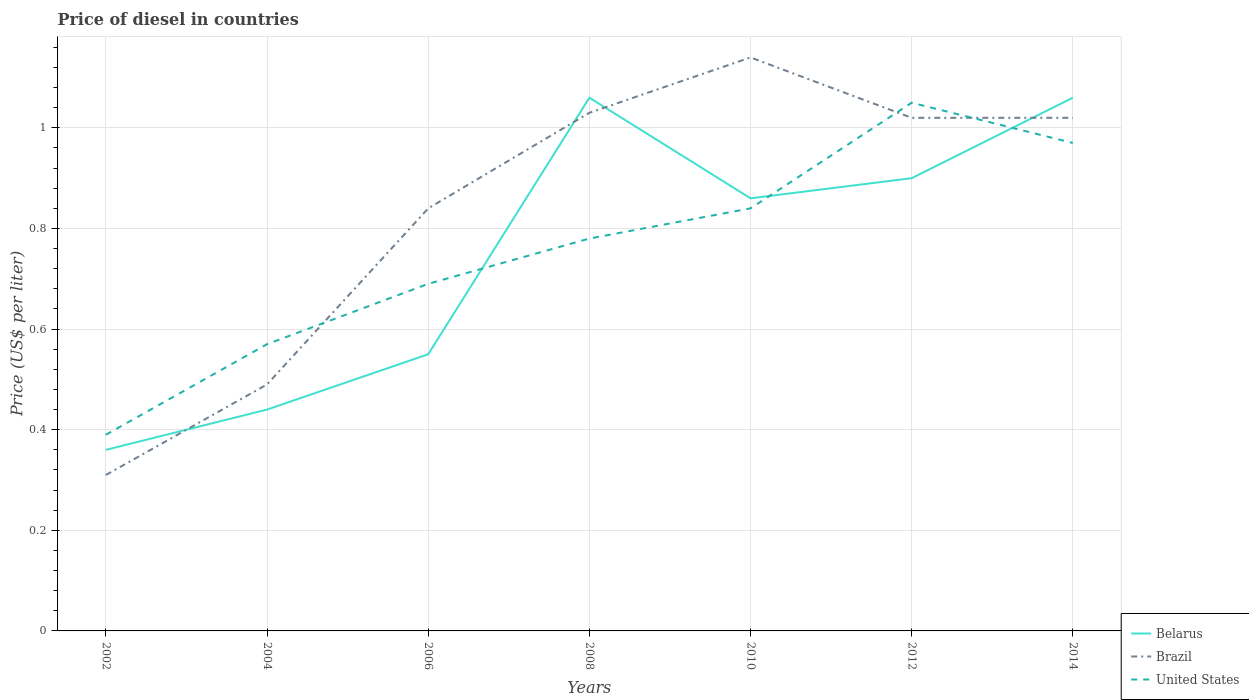How many different coloured lines are there?
Make the answer very short. 3. Does the line corresponding to Brazil intersect with the line corresponding to Belarus?
Make the answer very short. Yes. Across all years, what is the maximum price of diesel in Brazil?
Make the answer very short. 0.31. What is the total price of diesel in Belarus in the graph?
Offer a very short reply. -0.31. What is the difference between the highest and the second highest price of diesel in Brazil?
Provide a succinct answer. 0.83. Is the price of diesel in United States strictly greater than the price of diesel in Belarus over the years?
Make the answer very short. No. How many lines are there?
Ensure brevity in your answer.  3. How many years are there in the graph?
Provide a short and direct response. 7. What is the difference between two consecutive major ticks on the Y-axis?
Offer a terse response. 0.2. Does the graph contain grids?
Offer a very short reply. Yes. How many legend labels are there?
Offer a very short reply. 3. What is the title of the graph?
Give a very brief answer. Price of diesel in countries. What is the label or title of the Y-axis?
Ensure brevity in your answer.  Price (US$ per liter). What is the Price (US$ per liter) of Belarus in 2002?
Provide a succinct answer. 0.36. What is the Price (US$ per liter) of Brazil in 2002?
Your response must be concise. 0.31. What is the Price (US$ per liter) of United States in 2002?
Give a very brief answer. 0.39. What is the Price (US$ per liter) in Belarus in 2004?
Your response must be concise. 0.44. What is the Price (US$ per liter) in Brazil in 2004?
Provide a succinct answer. 0.49. What is the Price (US$ per liter) in United States in 2004?
Offer a terse response. 0.57. What is the Price (US$ per liter) in Belarus in 2006?
Offer a very short reply. 0.55. What is the Price (US$ per liter) in Brazil in 2006?
Your response must be concise. 0.84. What is the Price (US$ per liter) in United States in 2006?
Make the answer very short. 0.69. What is the Price (US$ per liter) of Belarus in 2008?
Offer a terse response. 1.06. What is the Price (US$ per liter) of Brazil in 2008?
Keep it short and to the point. 1.03. What is the Price (US$ per liter) in United States in 2008?
Your answer should be very brief. 0.78. What is the Price (US$ per liter) in Belarus in 2010?
Your answer should be very brief. 0.86. What is the Price (US$ per liter) in Brazil in 2010?
Keep it short and to the point. 1.14. What is the Price (US$ per liter) of United States in 2010?
Offer a terse response. 0.84. What is the Price (US$ per liter) in United States in 2012?
Provide a short and direct response. 1.05. What is the Price (US$ per liter) in Belarus in 2014?
Offer a terse response. 1.06. Across all years, what is the maximum Price (US$ per liter) of Belarus?
Keep it short and to the point. 1.06. Across all years, what is the maximum Price (US$ per liter) in Brazil?
Provide a short and direct response. 1.14. Across all years, what is the minimum Price (US$ per liter) of Belarus?
Keep it short and to the point. 0.36. Across all years, what is the minimum Price (US$ per liter) in Brazil?
Provide a short and direct response. 0.31. Across all years, what is the minimum Price (US$ per liter) in United States?
Provide a short and direct response. 0.39. What is the total Price (US$ per liter) of Belarus in the graph?
Provide a short and direct response. 5.23. What is the total Price (US$ per liter) of Brazil in the graph?
Offer a terse response. 5.85. What is the total Price (US$ per liter) of United States in the graph?
Give a very brief answer. 5.29. What is the difference between the Price (US$ per liter) of Belarus in 2002 and that in 2004?
Offer a terse response. -0.08. What is the difference between the Price (US$ per liter) of Brazil in 2002 and that in 2004?
Your answer should be very brief. -0.18. What is the difference between the Price (US$ per liter) in United States in 2002 and that in 2004?
Offer a very short reply. -0.18. What is the difference between the Price (US$ per liter) in Belarus in 2002 and that in 2006?
Offer a very short reply. -0.19. What is the difference between the Price (US$ per liter) in Brazil in 2002 and that in 2006?
Offer a very short reply. -0.53. What is the difference between the Price (US$ per liter) in Brazil in 2002 and that in 2008?
Make the answer very short. -0.72. What is the difference between the Price (US$ per liter) of United States in 2002 and that in 2008?
Your response must be concise. -0.39. What is the difference between the Price (US$ per liter) in Belarus in 2002 and that in 2010?
Offer a terse response. -0.5. What is the difference between the Price (US$ per liter) of Brazil in 2002 and that in 2010?
Ensure brevity in your answer.  -0.83. What is the difference between the Price (US$ per liter) of United States in 2002 and that in 2010?
Make the answer very short. -0.45. What is the difference between the Price (US$ per liter) in Belarus in 2002 and that in 2012?
Provide a succinct answer. -0.54. What is the difference between the Price (US$ per liter) in Brazil in 2002 and that in 2012?
Your answer should be compact. -0.71. What is the difference between the Price (US$ per liter) in United States in 2002 and that in 2012?
Your answer should be compact. -0.66. What is the difference between the Price (US$ per liter) in Brazil in 2002 and that in 2014?
Your response must be concise. -0.71. What is the difference between the Price (US$ per liter) in United States in 2002 and that in 2014?
Ensure brevity in your answer.  -0.58. What is the difference between the Price (US$ per liter) in Belarus in 2004 and that in 2006?
Provide a succinct answer. -0.11. What is the difference between the Price (US$ per liter) of Brazil in 2004 and that in 2006?
Keep it short and to the point. -0.35. What is the difference between the Price (US$ per liter) of United States in 2004 and that in 2006?
Provide a short and direct response. -0.12. What is the difference between the Price (US$ per liter) in Belarus in 2004 and that in 2008?
Offer a terse response. -0.62. What is the difference between the Price (US$ per liter) in Brazil in 2004 and that in 2008?
Offer a terse response. -0.54. What is the difference between the Price (US$ per liter) of United States in 2004 and that in 2008?
Give a very brief answer. -0.21. What is the difference between the Price (US$ per liter) of Belarus in 2004 and that in 2010?
Offer a very short reply. -0.42. What is the difference between the Price (US$ per liter) of Brazil in 2004 and that in 2010?
Keep it short and to the point. -0.65. What is the difference between the Price (US$ per liter) of United States in 2004 and that in 2010?
Provide a succinct answer. -0.27. What is the difference between the Price (US$ per liter) in Belarus in 2004 and that in 2012?
Provide a short and direct response. -0.46. What is the difference between the Price (US$ per liter) of Brazil in 2004 and that in 2012?
Keep it short and to the point. -0.53. What is the difference between the Price (US$ per liter) in United States in 2004 and that in 2012?
Your answer should be compact. -0.48. What is the difference between the Price (US$ per liter) in Belarus in 2004 and that in 2014?
Your response must be concise. -0.62. What is the difference between the Price (US$ per liter) in Brazil in 2004 and that in 2014?
Offer a very short reply. -0.53. What is the difference between the Price (US$ per liter) in Belarus in 2006 and that in 2008?
Your response must be concise. -0.51. What is the difference between the Price (US$ per liter) of Brazil in 2006 and that in 2008?
Keep it short and to the point. -0.19. What is the difference between the Price (US$ per liter) in United States in 2006 and that in 2008?
Make the answer very short. -0.09. What is the difference between the Price (US$ per liter) in Belarus in 2006 and that in 2010?
Your answer should be very brief. -0.31. What is the difference between the Price (US$ per liter) in United States in 2006 and that in 2010?
Your answer should be compact. -0.15. What is the difference between the Price (US$ per liter) of Belarus in 2006 and that in 2012?
Offer a terse response. -0.35. What is the difference between the Price (US$ per liter) of Brazil in 2006 and that in 2012?
Offer a very short reply. -0.18. What is the difference between the Price (US$ per liter) in United States in 2006 and that in 2012?
Give a very brief answer. -0.36. What is the difference between the Price (US$ per liter) of Belarus in 2006 and that in 2014?
Keep it short and to the point. -0.51. What is the difference between the Price (US$ per liter) in Brazil in 2006 and that in 2014?
Provide a short and direct response. -0.18. What is the difference between the Price (US$ per liter) in United States in 2006 and that in 2014?
Your answer should be very brief. -0.28. What is the difference between the Price (US$ per liter) of Belarus in 2008 and that in 2010?
Your response must be concise. 0.2. What is the difference between the Price (US$ per liter) in Brazil in 2008 and that in 2010?
Make the answer very short. -0.11. What is the difference between the Price (US$ per liter) in United States in 2008 and that in 2010?
Make the answer very short. -0.06. What is the difference between the Price (US$ per liter) in Belarus in 2008 and that in 2012?
Keep it short and to the point. 0.16. What is the difference between the Price (US$ per liter) in Brazil in 2008 and that in 2012?
Provide a short and direct response. 0.01. What is the difference between the Price (US$ per liter) in United States in 2008 and that in 2012?
Your answer should be very brief. -0.27. What is the difference between the Price (US$ per liter) in United States in 2008 and that in 2014?
Offer a terse response. -0.19. What is the difference between the Price (US$ per liter) of Belarus in 2010 and that in 2012?
Give a very brief answer. -0.04. What is the difference between the Price (US$ per liter) in Brazil in 2010 and that in 2012?
Offer a terse response. 0.12. What is the difference between the Price (US$ per liter) in United States in 2010 and that in 2012?
Provide a succinct answer. -0.21. What is the difference between the Price (US$ per liter) in Brazil in 2010 and that in 2014?
Provide a short and direct response. 0.12. What is the difference between the Price (US$ per liter) of United States in 2010 and that in 2014?
Provide a short and direct response. -0.13. What is the difference between the Price (US$ per liter) in Belarus in 2012 and that in 2014?
Your response must be concise. -0.16. What is the difference between the Price (US$ per liter) of Brazil in 2012 and that in 2014?
Your answer should be very brief. 0. What is the difference between the Price (US$ per liter) of United States in 2012 and that in 2014?
Offer a very short reply. 0.08. What is the difference between the Price (US$ per liter) in Belarus in 2002 and the Price (US$ per liter) in Brazil in 2004?
Ensure brevity in your answer.  -0.13. What is the difference between the Price (US$ per liter) in Belarus in 2002 and the Price (US$ per liter) in United States in 2004?
Your answer should be compact. -0.21. What is the difference between the Price (US$ per liter) in Brazil in 2002 and the Price (US$ per liter) in United States in 2004?
Make the answer very short. -0.26. What is the difference between the Price (US$ per liter) of Belarus in 2002 and the Price (US$ per liter) of Brazil in 2006?
Provide a succinct answer. -0.48. What is the difference between the Price (US$ per liter) of Belarus in 2002 and the Price (US$ per liter) of United States in 2006?
Keep it short and to the point. -0.33. What is the difference between the Price (US$ per liter) in Brazil in 2002 and the Price (US$ per liter) in United States in 2006?
Provide a short and direct response. -0.38. What is the difference between the Price (US$ per liter) of Belarus in 2002 and the Price (US$ per liter) of Brazil in 2008?
Your response must be concise. -0.67. What is the difference between the Price (US$ per liter) in Belarus in 2002 and the Price (US$ per liter) in United States in 2008?
Make the answer very short. -0.42. What is the difference between the Price (US$ per liter) of Brazil in 2002 and the Price (US$ per liter) of United States in 2008?
Ensure brevity in your answer.  -0.47. What is the difference between the Price (US$ per liter) in Belarus in 2002 and the Price (US$ per liter) in Brazil in 2010?
Provide a short and direct response. -0.78. What is the difference between the Price (US$ per liter) of Belarus in 2002 and the Price (US$ per liter) of United States in 2010?
Offer a terse response. -0.48. What is the difference between the Price (US$ per liter) of Brazil in 2002 and the Price (US$ per liter) of United States in 2010?
Make the answer very short. -0.53. What is the difference between the Price (US$ per liter) of Belarus in 2002 and the Price (US$ per liter) of Brazil in 2012?
Give a very brief answer. -0.66. What is the difference between the Price (US$ per liter) in Belarus in 2002 and the Price (US$ per liter) in United States in 2012?
Your answer should be compact. -0.69. What is the difference between the Price (US$ per liter) of Brazil in 2002 and the Price (US$ per liter) of United States in 2012?
Offer a terse response. -0.74. What is the difference between the Price (US$ per liter) of Belarus in 2002 and the Price (US$ per liter) of Brazil in 2014?
Offer a terse response. -0.66. What is the difference between the Price (US$ per liter) in Belarus in 2002 and the Price (US$ per liter) in United States in 2014?
Your answer should be compact. -0.61. What is the difference between the Price (US$ per liter) of Brazil in 2002 and the Price (US$ per liter) of United States in 2014?
Give a very brief answer. -0.66. What is the difference between the Price (US$ per liter) of Belarus in 2004 and the Price (US$ per liter) of United States in 2006?
Make the answer very short. -0.25. What is the difference between the Price (US$ per liter) in Belarus in 2004 and the Price (US$ per liter) in Brazil in 2008?
Your answer should be compact. -0.59. What is the difference between the Price (US$ per liter) in Belarus in 2004 and the Price (US$ per liter) in United States in 2008?
Your response must be concise. -0.34. What is the difference between the Price (US$ per liter) of Brazil in 2004 and the Price (US$ per liter) of United States in 2008?
Offer a very short reply. -0.29. What is the difference between the Price (US$ per liter) in Belarus in 2004 and the Price (US$ per liter) in Brazil in 2010?
Give a very brief answer. -0.7. What is the difference between the Price (US$ per liter) in Brazil in 2004 and the Price (US$ per liter) in United States in 2010?
Ensure brevity in your answer.  -0.35. What is the difference between the Price (US$ per liter) in Belarus in 2004 and the Price (US$ per liter) in Brazil in 2012?
Offer a very short reply. -0.58. What is the difference between the Price (US$ per liter) of Belarus in 2004 and the Price (US$ per liter) of United States in 2012?
Keep it short and to the point. -0.61. What is the difference between the Price (US$ per liter) of Brazil in 2004 and the Price (US$ per liter) of United States in 2012?
Your response must be concise. -0.56. What is the difference between the Price (US$ per liter) of Belarus in 2004 and the Price (US$ per liter) of Brazil in 2014?
Offer a very short reply. -0.58. What is the difference between the Price (US$ per liter) of Belarus in 2004 and the Price (US$ per liter) of United States in 2014?
Your response must be concise. -0.53. What is the difference between the Price (US$ per liter) in Brazil in 2004 and the Price (US$ per liter) in United States in 2014?
Make the answer very short. -0.48. What is the difference between the Price (US$ per liter) in Belarus in 2006 and the Price (US$ per liter) in Brazil in 2008?
Your answer should be compact. -0.48. What is the difference between the Price (US$ per liter) of Belarus in 2006 and the Price (US$ per liter) of United States in 2008?
Make the answer very short. -0.23. What is the difference between the Price (US$ per liter) in Brazil in 2006 and the Price (US$ per liter) in United States in 2008?
Provide a short and direct response. 0.06. What is the difference between the Price (US$ per liter) of Belarus in 2006 and the Price (US$ per liter) of Brazil in 2010?
Give a very brief answer. -0.59. What is the difference between the Price (US$ per liter) of Belarus in 2006 and the Price (US$ per liter) of United States in 2010?
Keep it short and to the point. -0.29. What is the difference between the Price (US$ per liter) in Brazil in 2006 and the Price (US$ per liter) in United States in 2010?
Provide a succinct answer. 0. What is the difference between the Price (US$ per liter) of Belarus in 2006 and the Price (US$ per liter) of Brazil in 2012?
Ensure brevity in your answer.  -0.47. What is the difference between the Price (US$ per liter) in Brazil in 2006 and the Price (US$ per liter) in United States in 2012?
Give a very brief answer. -0.21. What is the difference between the Price (US$ per liter) of Belarus in 2006 and the Price (US$ per liter) of Brazil in 2014?
Your answer should be compact. -0.47. What is the difference between the Price (US$ per liter) of Belarus in 2006 and the Price (US$ per liter) of United States in 2014?
Provide a short and direct response. -0.42. What is the difference between the Price (US$ per liter) in Brazil in 2006 and the Price (US$ per liter) in United States in 2014?
Your answer should be very brief. -0.13. What is the difference between the Price (US$ per liter) of Belarus in 2008 and the Price (US$ per liter) of Brazil in 2010?
Offer a very short reply. -0.08. What is the difference between the Price (US$ per liter) of Belarus in 2008 and the Price (US$ per liter) of United States in 2010?
Give a very brief answer. 0.22. What is the difference between the Price (US$ per liter) in Brazil in 2008 and the Price (US$ per liter) in United States in 2010?
Ensure brevity in your answer.  0.19. What is the difference between the Price (US$ per liter) in Belarus in 2008 and the Price (US$ per liter) in Brazil in 2012?
Your response must be concise. 0.04. What is the difference between the Price (US$ per liter) of Brazil in 2008 and the Price (US$ per liter) of United States in 2012?
Ensure brevity in your answer.  -0.02. What is the difference between the Price (US$ per liter) of Belarus in 2008 and the Price (US$ per liter) of United States in 2014?
Keep it short and to the point. 0.09. What is the difference between the Price (US$ per liter) of Belarus in 2010 and the Price (US$ per liter) of Brazil in 2012?
Provide a short and direct response. -0.16. What is the difference between the Price (US$ per liter) in Belarus in 2010 and the Price (US$ per liter) in United States in 2012?
Offer a very short reply. -0.19. What is the difference between the Price (US$ per liter) in Brazil in 2010 and the Price (US$ per liter) in United States in 2012?
Keep it short and to the point. 0.09. What is the difference between the Price (US$ per liter) in Belarus in 2010 and the Price (US$ per liter) in Brazil in 2014?
Provide a short and direct response. -0.16. What is the difference between the Price (US$ per liter) in Belarus in 2010 and the Price (US$ per liter) in United States in 2014?
Provide a succinct answer. -0.11. What is the difference between the Price (US$ per liter) in Brazil in 2010 and the Price (US$ per liter) in United States in 2014?
Your answer should be very brief. 0.17. What is the difference between the Price (US$ per liter) in Belarus in 2012 and the Price (US$ per liter) in Brazil in 2014?
Provide a short and direct response. -0.12. What is the difference between the Price (US$ per liter) of Belarus in 2012 and the Price (US$ per liter) of United States in 2014?
Ensure brevity in your answer.  -0.07. What is the difference between the Price (US$ per liter) in Brazil in 2012 and the Price (US$ per liter) in United States in 2014?
Provide a short and direct response. 0.05. What is the average Price (US$ per liter) in Belarus per year?
Offer a terse response. 0.75. What is the average Price (US$ per liter) in Brazil per year?
Provide a succinct answer. 0.84. What is the average Price (US$ per liter) in United States per year?
Provide a short and direct response. 0.76. In the year 2002, what is the difference between the Price (US$ per liter) in Belarus and Price (US$ per liter) in Brazil?
Your response must be concise. 0.05. In the year 2002, what is the difference between the Price (US$ per liter) in Belarus and Price (US$ per liter) in United States?
Ensure brevity in your answer.  -0.03. In the year 2002, what is the difference between the Price (US$ per liter) in Brazil and Price (US$ per liter) in United States?
Give a very brief answer. -0.08. In the year 2004, what is the difference between the Price (US$ per liter) of Belarus and Price (US$ per liter) of United States?
Your answer should be very brief. -0.13. In the year 2004, what is the difference between the Price (US$ per liter) of Brazil and Price (US$ per liter) of United States?
Give a very brief answer. -0.08. In the year 2006, what is the difference between the Price (US$ per liter) of Belarus and Price (US$ per liter) of Brazil?
Your answer should be very brief. -0.29. In the year 2006, what is the difference between the Price (US$ per liter) of Belarus and Price (US$ per liter) of United States?
Offer a very short reply. -0.14. In the year 2006, what is the difference between the Price (US$ per liter) in Brazil and Price (US$ per liter) in United States?
Your response must be concise. 0.15. In the year 2008, what is the difference between the Price (US$ per liter) in Belarus and Price (US$ per liter) in Brazil?
Your answer should be very brief. 0.03. In the year 2008, what is the difference between the Price (US$ per liter) in Belarus and Price (US$ per liter) in United States?
Your response must be concise. 0.28. In the year 2010, what is the difference between the Price (US$ per liter) in Belarus and Price (US$ per liter) in Brazil?
Ensure brevity in your answer.  -0.28. In the year 2012, what is the difference between the Price (US$ per liter) of Belarus and Price (US$ per liter) of Brazil?
Give a very brief answer. -0.12. In the year 2012, what is the difference between the Price (US$ per liter) of Belarus and Price (US$ per liter) of United States?
Make the answer very short. -0.15. In the year 2012, what is the difference between the Price (US$ per liter) in Brazil and Price (US$ per liter) in United States?
Your answer should be compact. -0.03. In the year 2014, what is the difference between the Price (US$ per liter) of Belarus and Price (US$ per liter) of United States?
Your answer should be compact. 0.09. What is the ratio of the Price (US$ per liter) in Belarus in 2002 to that in 2004?
Make the answer very short. 0.82. What is the ratio of the Price (US$ per liter) in Brazil in 2002 to that in 2004?
Provide a succinct answer. 0.63. What is the ratio of the Price (US$ per liter) in United States in 2002 to that in 2004?
Keep it short and to the point. 0.68. What is the ratio of the Price (US$ per liter) of Belarus in 2002 to that in 2006?
Offer a very short reply. 0.65. What is the ratio of the Price (US$ per liter) of Brazil in 2002 to that in 2006?
Keep it short and to the point. 0.37. What is the ratio of the Price (US$ per liter) of United States in 2002 to that in 2006?
Provide a short and direct response. 0.57. What is the ratio of the Price (US$ per liter) of Belarus in 2002 to that in 2008?
Offer a terse response. 0.34. What is the ratio of the Price (US$ per liter) of Brazil in 2002 to that in 2008?
Ensure brevity in your answer.  0.3. What is the ratio of the Price (US$ per liter) of United States in 2002 to that in 2008?
Offer a terse response. 0.5. What is the ratio of the Price (US$ per liter) in Belarus in 2002 to that in 2010?
Keep it short and to the point. 0.42. What is the ratio of the Price (US$ per liter) of Brazil in 2002 to that in 2010?
Offer a very short reply. 0.27. What is the ratio of the Price (US$ per liter) of United States in 2002 to that in 2010?
Offer a very short reply. 0.46. What is the ratio of the Price (US$ per liter) of Belarus in 2002 to that in 2012?
Your answer should be compact. 0.4. What is the ratio of the Price (US$ per liter) in Brazil in 2002 to that in 2012?
Offer a very short reply. 0.3. What is the ratio of the Price (US$ per liter) in United States in 2002 to that in 2012?
Keep it short and to the point. 0.37. What is the ratio of the Price (US$ per liter) in Belarus in 2002 to that in 2014?
Your answer should be very brief. 0.34. What is the ratio of the Price (US$ per liter) in Brazil in 2002 to that in 2014?
Ensure brevity in your answer.  0.3. What is the ratio of the Price (US$ per liter) in United States in 2002 to that in 2014?
Provide a succinct answer. 0.4. What is the ratio of the Price (US$ per liter) of Belarus in 2004 to that in 2006?
Keep it short and to the point. 0.8. What is the ratio of the Price (US$ per liter) in Brazil in 2004 to that in 2006?
Provide a succinct answer. 0.58. What is the ratio of the Price (US$ per liter) in United States in 2004 to that in 2006?
Your response must be concise. 0.83. What is the ratio of the Price (US$ per liter) of Belarus in 2004 to that in 2008?
Give a very brief answer. 0.42. What is the ratio of the Price (US$ per liter) in Brazil in 2004 to that in 2008?
Provide a short and direct response. 0.48. What is the ratio of the Price (US$ per liter) of United States in 2004 to that in 2008?
Keep it short and to the point. 0.73. What is the ratio of the Price (US$ per liter) in Belarus in 2004 to that in 2010?
Provide a succinct answer. 0.51. What is the ratio of the Price (US$ per liter) in Brazil in 2004 to that in 2010?
Your answer should be compact. 0.43. What is the ratio of the Price (US$ per liter) in United States in 2004 to that in 2010?
Provide a succinct answer. 0.68. What is the ratio of the Price (US$ per liter) of Belarus in 2004 to that in 2012?
Your response must be concise. 0.49. What is the ratio of the Price (US$ per liter) of Brazil in 2004 to that in 2012?
Ensure brevity in your answer.  0.48. What is the ratio of the Price (US$ per liter) of United States in 2004 to that in 2012?
Your response must be concise. 0.54. What is the ratio of the Price (US$ per liter) of Belarus in 2004 to that in 2014?
Your answer should be compact. 0.42. What is the ratio of the Price (US$ per liter) of Brazil in 2004 to that in 2014?
Offer a very short reply. 0.48. What is the ratio of the Price (US$ per liter) in United States in 2004 to that in 2014?
Provide a short and direct response. 0.59. What is the ratio of the Price (US$ per liter) in Belarus in 2006 to that in 2008?
Offer a very short reply. 0.52. What is the ratio of the Price (US$ per liter) of Brazil in 2006 to that in 2008?
Your answer should be compact. 0.82. What is the ratio of the Price (US$ per liter) of United States in 2006 to that in 2008?
Keep it short and to the point. 0.88. What is the ratio of the Price (US$ per liter) in Belarus in 2006 to that in 2010?
Provide a succinct answer. 0.64. What is the ratio of the Price (US$ per liter) of Brazil in 2006 to that in 2010?
Offer a terse response. 0.74. What is the ratio of the Price (US$ per liter) in United States in 2006 to that in 2010?
Provide a succinct answer. 0.82. What is the ratio of the Price (US$ per liter) in Belarus in 2006 to that in 2012?
Your response must be concise. 0.61. What is the ratio of the Price (US$ per liter) of Brazil in 2006 to that in 2012?
Keep it short and to the point. 0.82. What is the ratio of the Price (US$ per liter) of United States in 2006 to that in 2012?
Provide a succinct answer. 0.66. What is the ratio of the Price (US$ per liter) in Belarus in 2006 to that in 2014?
Give a very brief answer. 0.52. What is the ratio of the Price (US$ per liter) of Brazil in 2006 to that in 2014?
Provide a succinct answer. 0.82. What is the ratio of the Price (US$ per liter) in United States in 2006 to that in 2014?
Your answer should be very brief. 0.71. What is the ratio of the Price (US$ per liter) in Belarus in 2008 to that in 2010?
Provide a short and direct response. 1.23. What is the ratio of the Price (US$ per liter) of Brazil in 2008 to that in 2010?
Provide a short and direct response. 0.9. What is the ratio of the Price (US$ per liter) of Belarus in 2008 to that in 2012?
Give a very brief answer. 1.18. What is the ratio of the Price (US$ per liter) in Brazil in 2008 to that in 2012?
Make the answer very short. 1.01. What is the ratio of the Price (US$ per liter) in United States in 2008 to that in 2012?
Offer a very short reply. 0.74. What is the ratio of the Price (US$ per liter) of Brazil in 2008 to that in 2014?
Provide a succinct answer. 1.01. What is the ratio of the Price (US$ per liter) in United States in 2008 to that in 2014?
Your answer should be compact. 0.8. What is the ratio of the Price (US$ per liter) of Belarus in 2010 to that in 2012?
Ensure brevity in your answer.  0.96. What is the ratio of the Price (US$ per liter) in Brazil in 2010 to that in 2012?
Make the answer very short. 1.12. What is the ratio of the Price (US$ per liter) of United States in 2010 to that in 2012?
Your answer should be compact. 0.8. What is the ratio of the Price (US$ per liter) of Belarus in 2010 to that in 2014?
Offer a very short reply. 0.81. What is the ratio of the Price (US$ per liter) of Brazil in 2010 to that in 2014?
Your answer should be compact. 1.12. What is the ratio of the Price (US$ per liter) in United States in 2010 to that in 2014?
Provide a succinct answer. 0.87. What is the ratio of the Price (US$ per liter) of Belarus in 2012 to that in 2014?
Provide a short and direct response. 0.85. What is the ratio of the Price (US$ per liter) of United States in 2012 to that in 2014?
Your answer should be very brief. 1.08. What is the difference between the highest and the second highest Price (US$ per liter) of Belarus?
Your answer should be compact. 0. What is the difference between the highest and the second highest Price (US$ per liter) in Brazil?
Provide a short and direct response. 0.11. What is the difference between the highest and the lowest Price (US$ per liter) in Brazil?
Your answer should be very brief. 0.83. What is the difference between the highest and the lowest Price (US$ per liter) of United States?
Offer a very short reply. 0.66. 